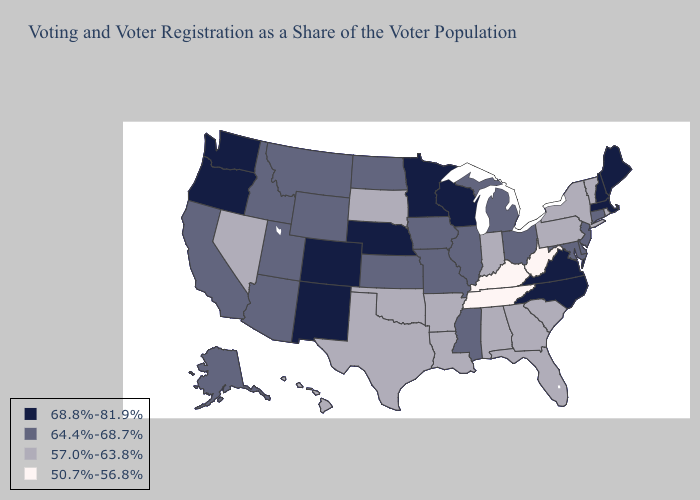Does Hawaii have a lower value than Tennessee?
Concise answer only. No. What is the lowest value in the USA?
Concise answer only. 50.7%-56.8%. What is the value of Michigan?
Answer briefly. 64.4%-68.7%. Which states hav the highest value in the South?
Quick response, please. North Carolina, Virginia. Name the states that have a value in the range 64.4%-68.7%?
Concise answer only. Alaska, Arizona, California, Connecticut, Delaware, Idaho, Illinois, Iowa, Kansas, Maryland, Michigan, Mississippi, Missouri, Montana, New Jersey, North Dakota, Ohio, Utah, Wyoming. Among the states that border Nebraska , which have the lowest value?
Short answer required. South Dakota. What is the value of Illinois?
Give a very brief answer. 64.4%-68.7%. How many symbols are there in the legend?
Answer briefly. 4. Which states have the lowest value in the USA?
Keep it brief. Kentucky, Tennessee, West Virginia. Is the legend a continuous bar?
Answer briefly. No. Does Michigan have a lower value than Nebraska?
Keep it brief. Yes. Does New York have the highest value in the USA?
Short answer required. No. Among the states that border Iowa , does Nebraska have the highest value?
Write a very short answer. Yes. Name the states that have a value in the range 64.4%-68.7%?
Give a very brief answer. Alaska, Arizona, California, Connecticut, Delaware, Idaho, Illinois, Iowa, Kansas, Maryland, Michigan, Mississippi, Missouri, Montana, New Jersey, North Dakota, Ohio, Utah, Wyoming. Does Kansas have a higher value than Florida?
Be succinct. Yes. 